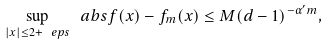<formula> <loc_0><loc_0><loc_500><loc_500>\sup _ { | x | \leq 2 + \ e p s } \ a b s { f ( x ) - f _ { m } ( x ) } & \leq M ( d - 1 ) ^ { - \alpha ^ { \prime } m } ,</formula> 